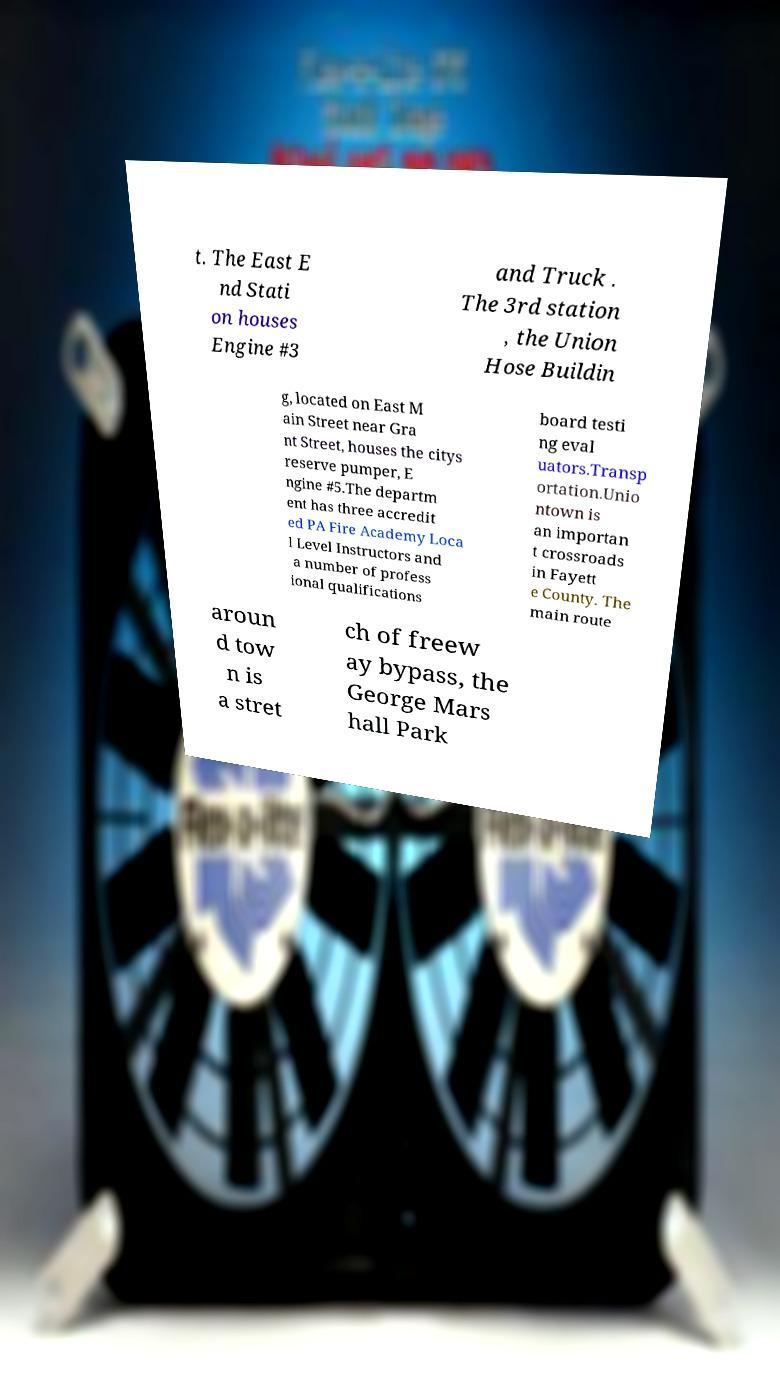Can you accurately transcribe the text from the provided image for me? t. The East E nd Stati on houses Engine #3 and Truck . The 3rd station , the Union Hose Buildin g, located on East M ain Street near Gra nt Street, houses the citys reserve pumper, E ngine #5.The departm ent has three accredit ed PA Fire Academy Loca l Level Instructors and a number of profess ional qualifications board testi ng eval uators.Transp ortation.Unio ntown is an importan t crossroads in Fayett e County. The main route aroun d tow n is a stret ch of freew ay bypass, the George Mars hall Park 